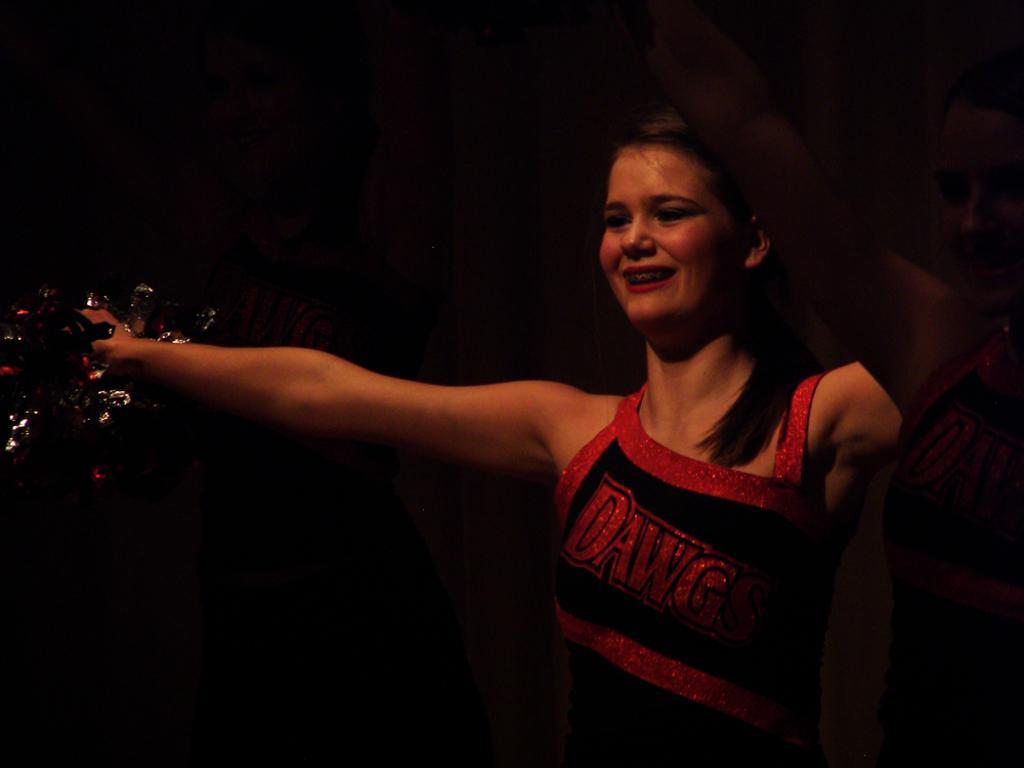Please provide a concise description of this image. This picture shows a woman with a smile on her face and she holds a color paper in her hand and we see another woman on the side. 